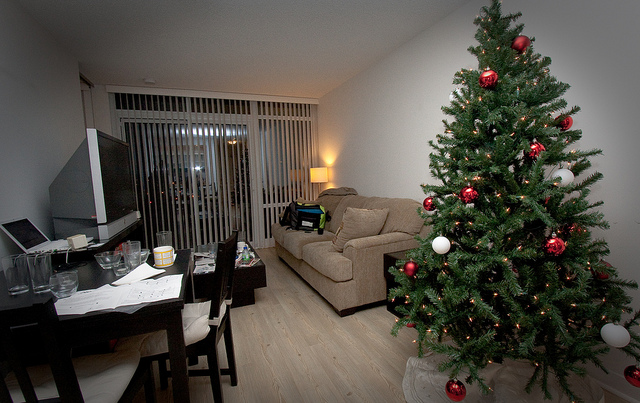How many lamps are off? Based on the image, all visible lamps seem to be off since the ambient light does not indicate any lamps being on. However, it's difficult to determine with certainty if there are any other lamps outside the frame of the photo that may be turned on. 